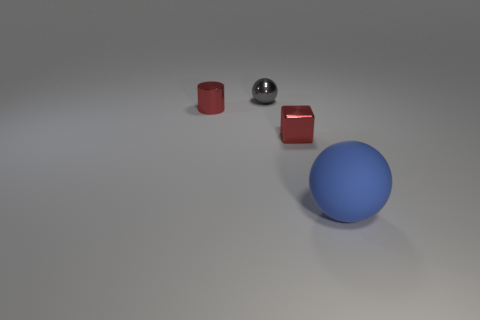Is there any other thing that has the same size as the blue rubber ball?
Your answer should be very brief. No. The gray object that is the same material as the tiny red cylinder is what shape?
Your response must be concise. Sphere. Is the small metallic cylinder the same color as the matte sphere?
Ensure brevity in your answer.  No. Is the material of the sphere to the left of the big ball the same as the ball to the right of the cube?
Offer a terse response. No. What number of things are red blocks or objects left of the big blue thing?
Give a very brief answer. 3. Is there any other thing that has the same material as the large object?
Ensure brevity in your answer.  No. The tiny thing that is the same color as the block is what shape?
Provide a short and direct response. Cylinder. What is the blue sphere made of?
Provide a short and direct response. Rubber. Are the big blue thing and the cylinder made of the same material?
Offer a terse response. No. How many metal things are objects or cylinders?
Your response must be concise. 3. 